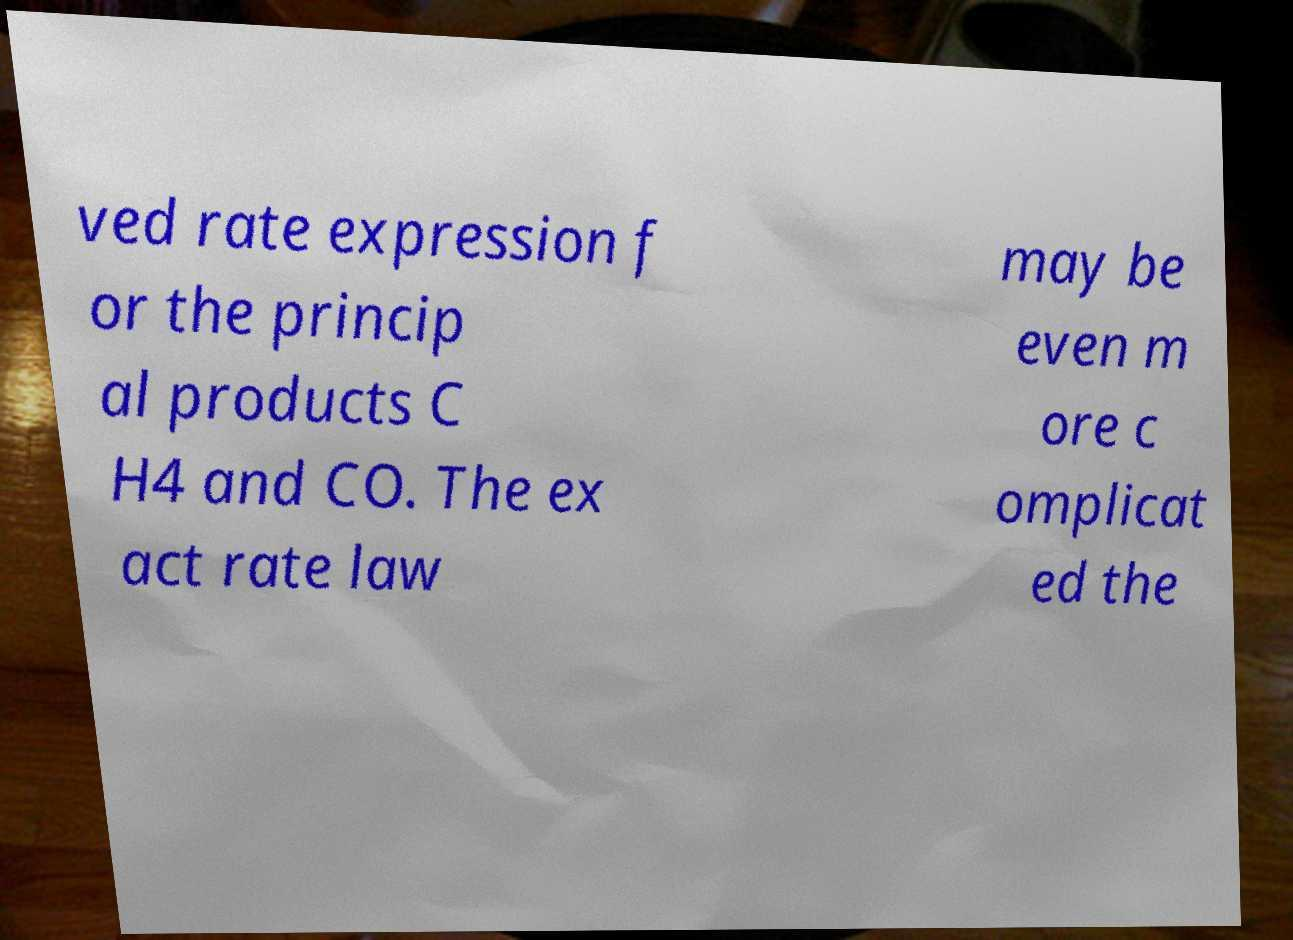Please read and relay the text visible in this image. What does it say? ved rate expression f or the princip al products C H4 and CO. The ex act rate law may be even m ore c omplicat ed the 